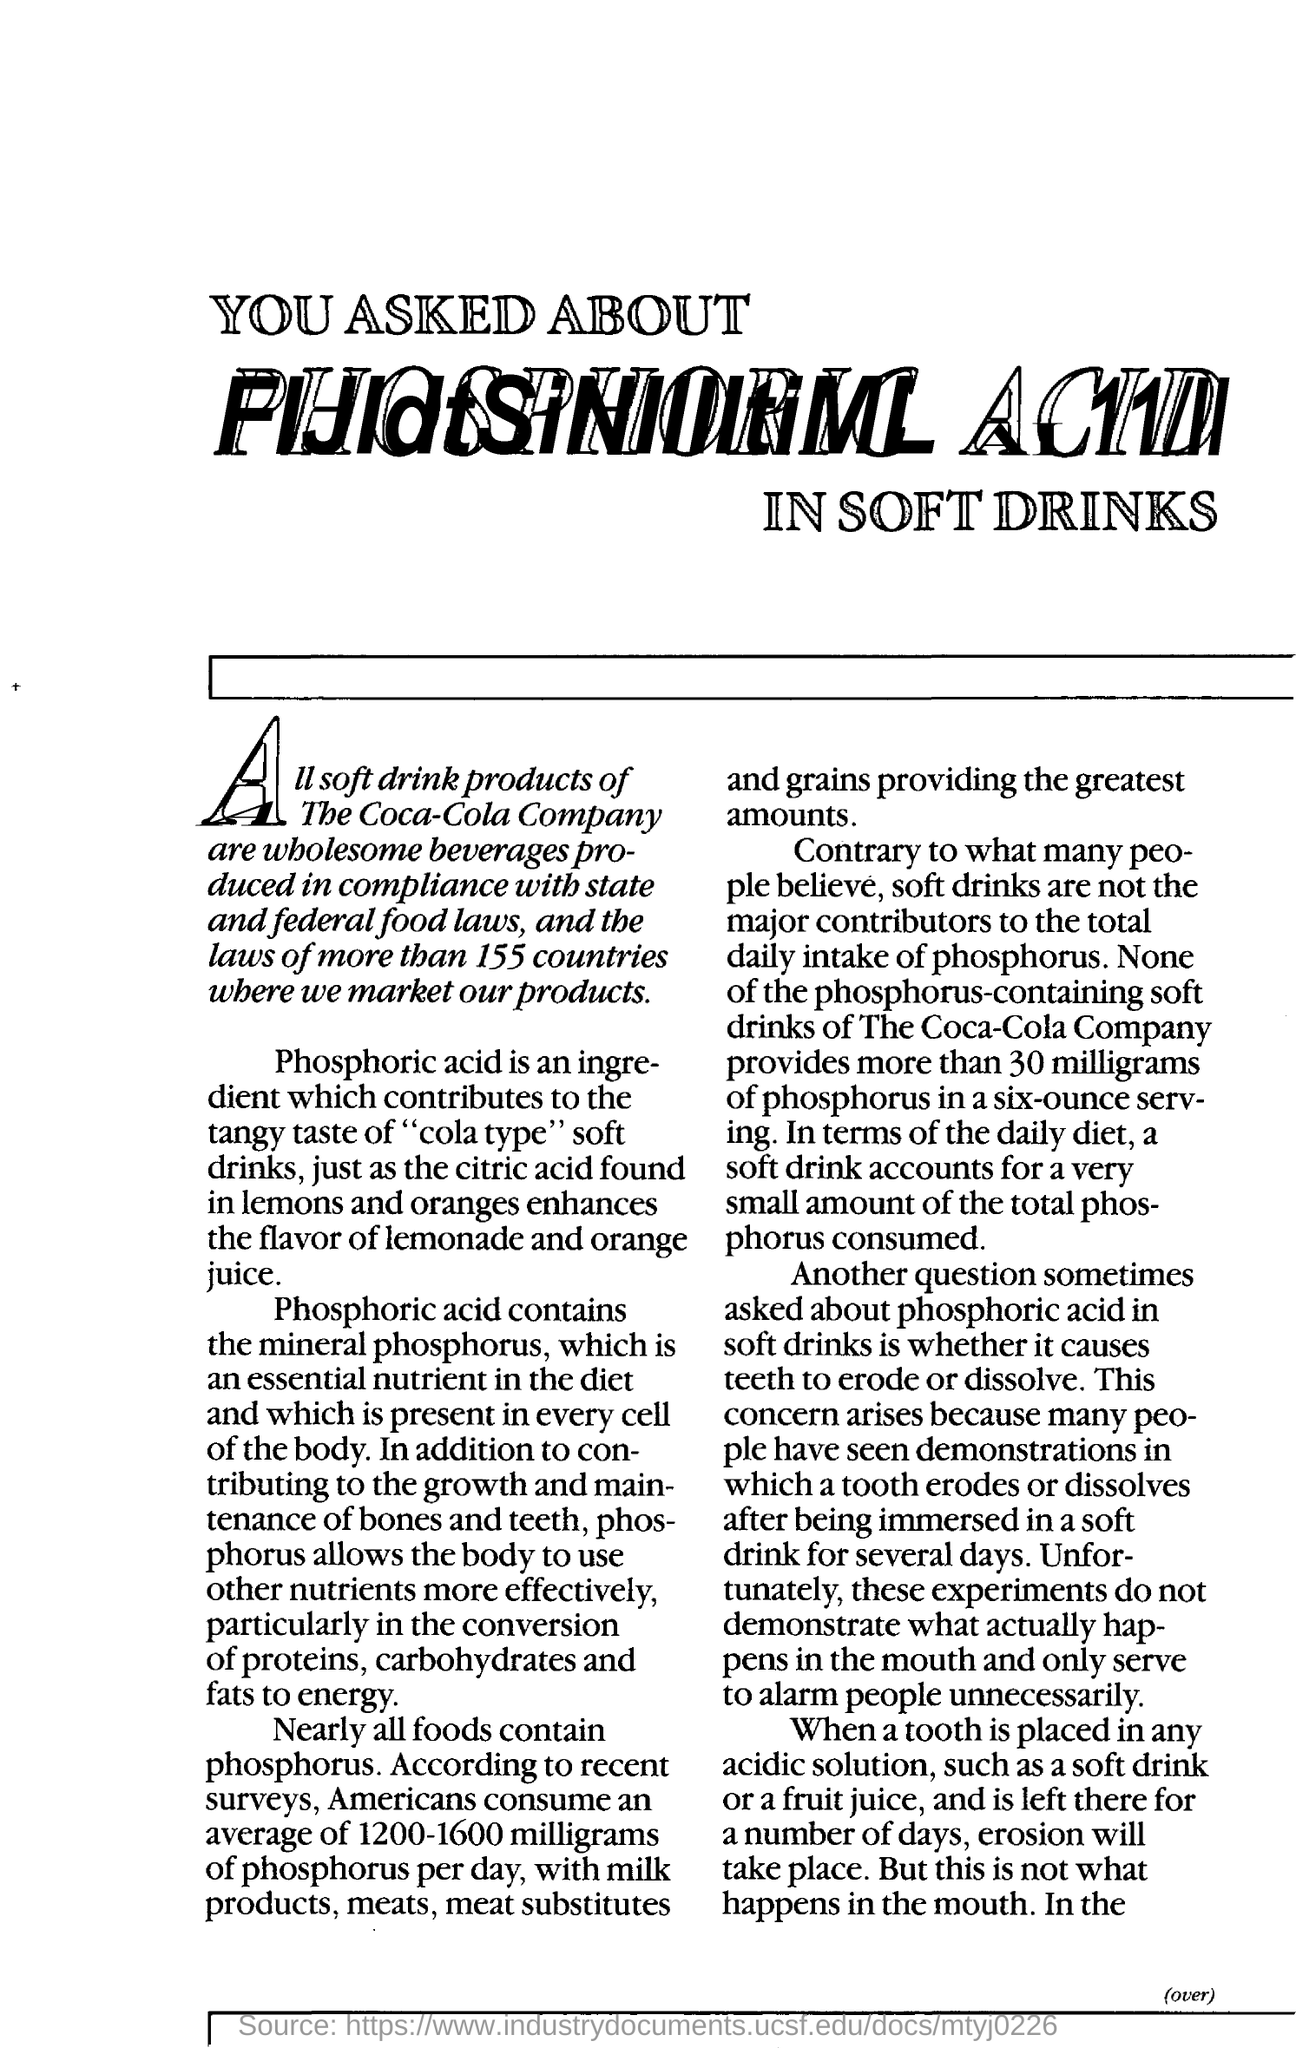What does the phosphoric acid contain ?
Offer a very short reply. Mineral phosphorous. How many milligrams americans consume phosphorus per day
Your answer should be very brief. 1200-1600 milligrams. What happens when a tooth is placed in an acid solution & is left there for a number of days?
Ensure brevity in your answer.  Erosion will take place. 